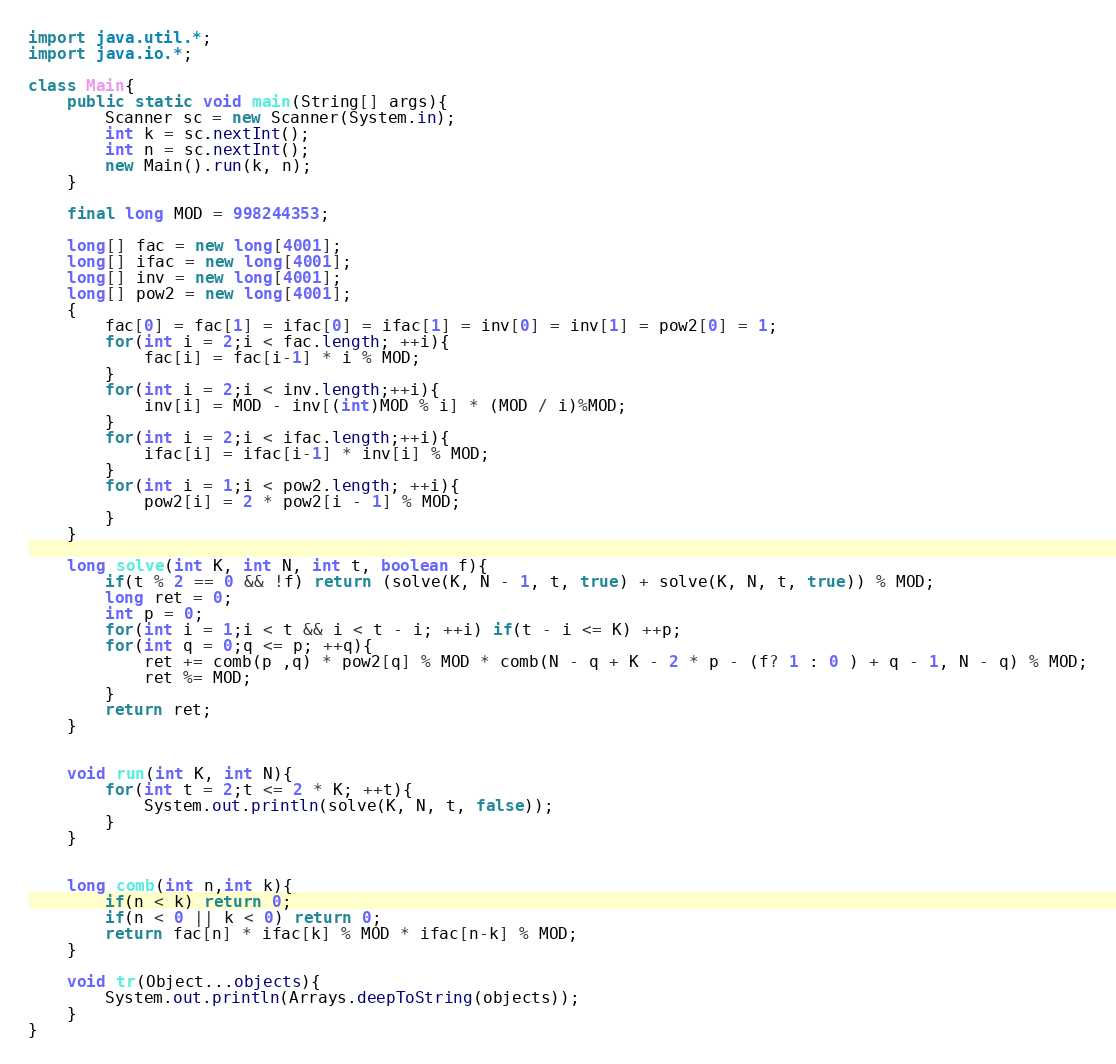<code> <loc_0><loc_0><loc_500><loc_500><_Java_>import java.util.*;
import java.io.*;

class Main{
    public static void main(String[] args){
        Scanner sc = new Scanner(System.in);
        int k = sc.nextInt();
        int n = sc.nextInt();
        new Main().run(k, n);
    }

    final long MOD = 998244353;

    long[] fac = new long[4001];
    long[] ifac = new long[4001];
    long[] inv = new long[4001];
    long[] pow2 = new long[4001];
    {
        fac[0] = fac[1] = ifac[0] = ifac[1] = inv[0] = inv[1] = pow2[0] = 1;
        for(int i = 2;i < fac.length; ++i){
            fac[i] = fac[i-1] * i % MOD;
        }
        for(int i = 2;i < inv.length;++i){
            inv[i] = MOD - inv[(int)MOD % i] * (MOD / i)%MOD;
        }
        for(int i = 2;i < ifac.length;++i){
            ifac[i] = ifac[i-1] * inv[i] % MOD;
        }
        for(int i = 1;i < pow2.length; ++i){
            pow2[i] = 2 * pow2[i - 1] % MOD;
        }
    }

    long solve(int K, int N, int t, boolean f){
        if(t % 2 == 0 && !f) return (solve(K, N - 1, t, true) + solve(K, N, t, true)) % MOD;
        long ret = 0;
        int p = 0;
        for(int i = 1;i < t && i < t - i; ++i) if(t - i <= K) ++p;
        for(int q = 0;q <= p; ++q){
            ret += comb(p ,q) * pow2[q] % MOD * comb(N - q + K - 2 * p - (f? 1 : 0 ) + q - 1, N - q) % MOD;
            ret %= MOD;
        }
        return ret;
    }


    void run(int K, int N){
        for(int t = 2;t <= 2 * K; ++t){
            System.out.println(solve(K, N, t, false));
        }
    }


    long comb(int n,int k){
        if(n < k) return 0;
        if(n < 0 || k < 0) return 0;
        return fac[n] * ifac[k] % MOD * ifac[n-k] % MOD;
    }

    void tr(Object...objects){
        System.out.println(Arrays.deepToString(objects));
    }
}</code> 